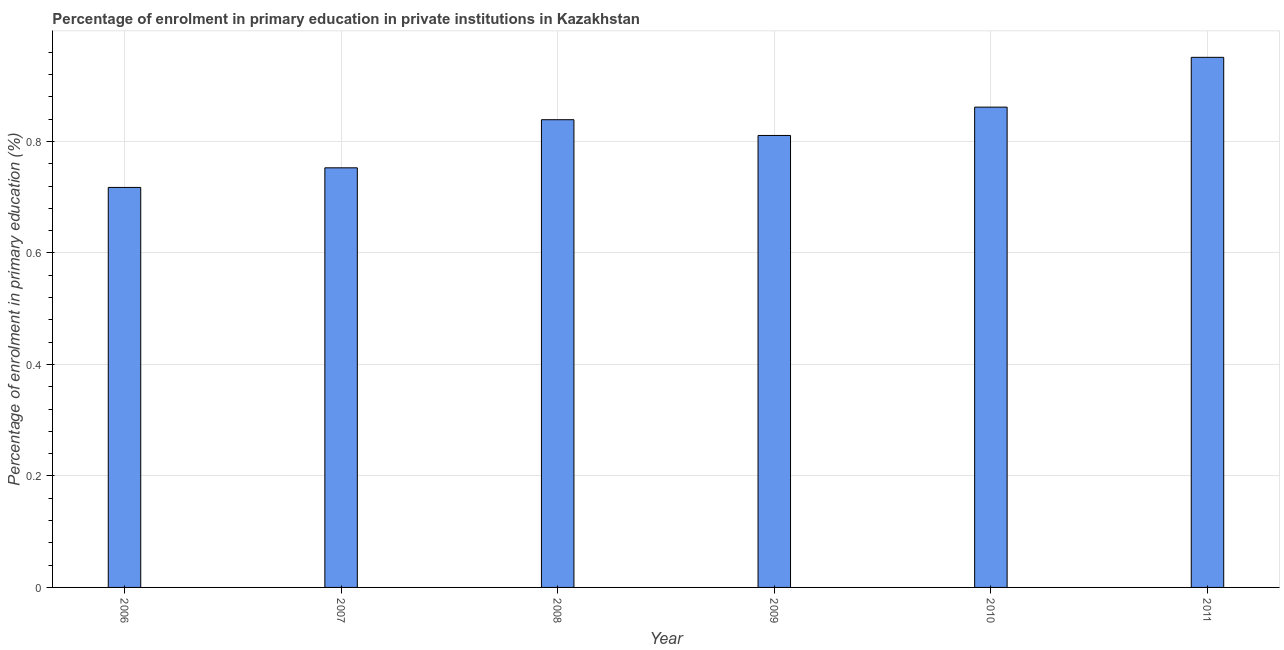What is the title of the graph?
Ensure brevity in your answer.  Percentage of enrolment in primary education in private institutions in Kazakhstan. What is the label or title of the Y-axis?
Give a very brief answer. Percentage of enrolment in primary education (%). What is the enrolment percentage in primary education in 2011?
Give a very brief answer. 0.95. Across all years, what is the maximum enrolment percentage in primary education?
Your answer should be very brief. 0.95. Across all years, what is the minimum enrolment percentage in primary education?
Your response must be concise. 0.72. What is the sum of the enrolment percentage in primary education?
Provide a succinct answer. 4.93. What is the difference between the enrolment percentage in primary education in 2007 and 2011?
Provide a succinct answer. -0.2. What is the average enrolment percentage in primary education per year?
Keep it short and to the point. 0.82. What is the median enrolment percentage in primary education?
Offer a terse response. 0.82. In how many years, is the enrolment percentage in primary education greater than 0.28 %?
Give a very brief answer. 6. Do a majority of the years between 2008 and 2011 (inclusive) have enrolment percentage in primary education greater than 0.36 %?
Provide a succinct answer. Yes. What is the ratio of the enrolment percentage in primary education in 2007 to that in 2008?
Ensure brevity in your answer.  0.9. What is the difference between the highest and the second highest enrolment percentage in primary education?
Make the answer very short. 0.09. What is the difference between the highest and the lowest enrolment percentage in primary education?
Ensure brevity in your answer.  0.23. Are all the bars in the graph horizontal?
Your answer should be very brief. No. What is the difference between two consecutive major ticks on the Y-axis?
Keep it short and to the point. 0.2. Are the values on the major ticks of Y-axis written in scientific E-notation?
Offer a terse response. No. What is the Percentage of enrolment in primary education (%) of 2006?
Ensure brevity in your answer.  0.72. What is the Percentage of enrolment in primary education (%) of 2007?
Your answer should be very brief. 0.75. What is the Percentage of enrolment in primary education (%) in 2008?
Give a very brief answer. 0.84. What is the Percentage of enrolment in primary education (%) of 2009?
Keep it short and to the point. 0.81. What is the Percentage of enrolment in primary education (%) of 2010?
Provide a succinct answer. 0.86. What is the Percentage of enrolment in primary education (%) of 2011?
Offer a terse response. 0.95. What is the difference between the Percentage of enrolment in primary education (%) in 2006 and 2007?
Make the answer very short. -0.04. What is the difference between the Percentage of enrolment in primary education (%) in 2006 and 2008?
Offer a terse response. -0.12. What is the difference between the Percentage of enrolment in primary education (%) in 2006 and 2009?
Provide a succinct answer. -0.09. What is the difference between the Percentage of enrolment in primary education (%) in 2006 and 2010?
Offer a terse response. -0.14. What is the difference between the Percentage of enrolment in primary education (%) in 2006 and 2011?
Provide a succinct answer. -0.23. What is the difference between the Percentage of enrolment in primary education (%) in 2007 and 2008?
Your answer should be very brief. -0.09. What is the difference between the Percentage of enrolment in primary education (%) in 2007 and 2009?
Give a very brief answer. -0.06. What is the difference between the Percentage of enrolment in primary education (%) in 2007 and 2010?
Make the answer very short. -0.11. What is the difference between the Percentage of enrolment in primary education (%) in 2007 and 2011?
Offer a terse response. -0.2. What is the difference between the Percentage of enrolment in primary education (%) in 2008 and 2009?
Ensure brevity in your answer.  0.03. What is the difference between the Percentage of enrolment in primary education (%) in 2008 and 2010?
Your answer should be compact. -0.02. What is the difference between the Percentage of enrolment in primary education (%) in 2008 and 2011?
Provide a succinct answer. -0.11. What is the difference between the Percentage of enrolment in primary education (%) in 2009 and 2010?
Your answer should be compact. -0.05. What is the difference between the Percentage of enrolment in primary education (%) in 2009 and 2011?
Your response must be concise. -0.14. What is the difference between the Percentage of enrolment in primary education (%) in 2010 and 2011?
Your response must be concise. -0.09. What is the ratio of the Percentage of enrolment in primary education (%) in 2006 to that in 2007?
Your answer should be very brief. 0.95. What is the ratio of the Percentage of enrolment in primary education (%) in 2006 to that in 2008?
Your answer should be compact. 0.85. What is the ratio of the Percentage of enrolment in primary education (%) in 2006 to that in 2009?
Ensure brevity in your answer.  0.89. What is the ratio of the Percentage of enrolment in primary education (%) in 2006 to that in 2010?
Provide a short and direct response. 0.83. What is the ratio of the Percentage of enrolment in primary education (%) in 2006 to that in 2011?
Ensure brevity in your answer.  0.76. What is the ratio of the Percentage of enrolment in primary education (%) in 2007 to that in 2008?
Offer a very short reply. 0.9. What is the ratio of the Percentage of enrolment in primary education (%) in 2007 to that in 2009?
Make the answer very short. 0.93. What is the ratio of the Percentage of enrolment in primary education (%) in 2007 to that in 2010?
Keep it short and to the point. 0.87. What is the ratio of the Percentage of enrolment in primary education (%) in 2007 to that in 2011?
Provide a short and direct response. 0.79. What is the ratio of the Percentage of enrolment in primary education (%) in 2008 to that in 2009?
Your response must be concise. 1.03. What is the ratio of the Percentage of enrolment in primary education (%) in 2008 to that in 2011?
Offer a terse response. 0.88. What is the ratio of the Percentage of enrolment in primary education (%) in 2009 to that in 2010?
Offer a very short reply. 0.94. What is the ratio of the Percentage of enrolment in primary education (%) in 2009 to that in 2011?
Ensure brevity in your answer.  0.85. What is the ratio of the Percentage of enrolment in primary education (%) in 2010 to that in 2011?
Offer a very short reply. 0.91. 